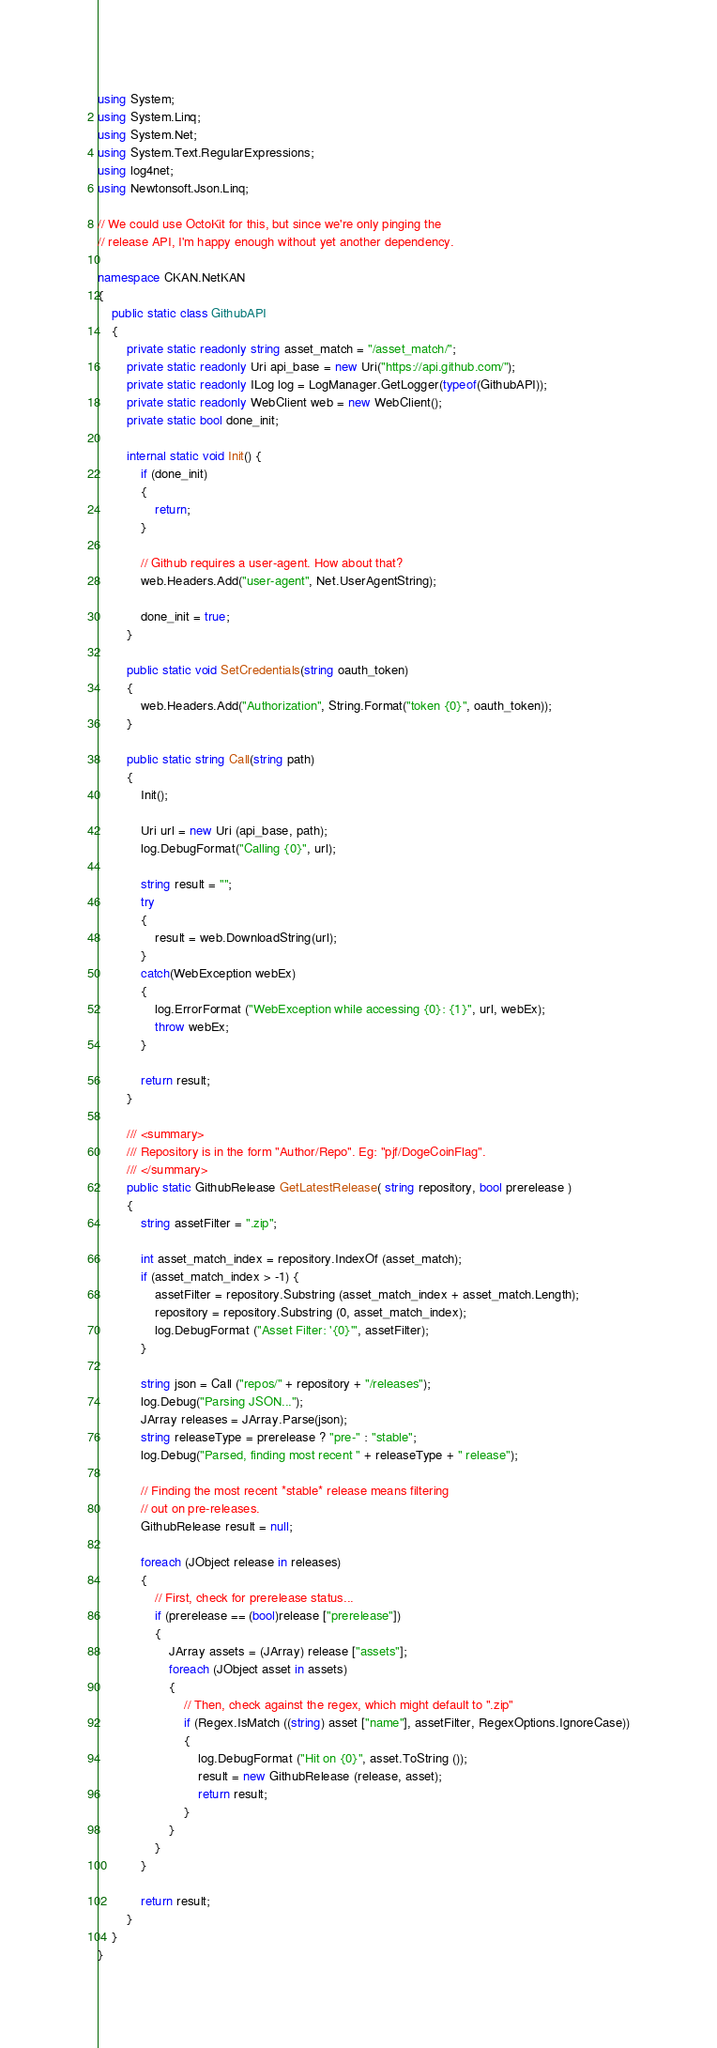<code> <loc_0><loc_0><loc_500><loc_500><_C#_>using System;
using System.Linq;
using System.Net;
using System.Text.RegularExpressions;
using log4net;
using Newtonsoft.Json.Linq;

// We could use OctoKit for this, but since we're only pinging the
// release API, I'm happy enough without yet another dependency.

namespace CKAN.NetKAN
{
    public static class GithubAPI
    {
        private static readonly string asset_match = "/asset_match/";
        private static readonly Uri api_base = new Uri("https://api.github.com/");
        private static readonly ILog log = LogManager.GetLogger(typeof(GithubAPI));
        private static readonly WebClient web = new WebClient();
        private static bool done_init;

        internal static void Init() {
            if (done_init)
            {
                return;
            }

            // Github requires a user-agent. How about that?
            web.Headers.Add("user-agent", Net.UserAgentString);

            done_init = true;
        }

        public static void SetCredentials(string oauth_token)
        {
            web.Headers.Add("Authorization", String.Format("token {0}", oauth_token));
        }

        public static string Call(string path)
        {
            Init();

            Uri url = new Uri (api_base, path);
            log.DebugFormat("Calling {0}", url);

            string result = "";
            try
            {
                result = web.DownloadString(url);
            }
            catch(WebException webEx)
            {
                log.ErrorFormat ("WebException while accessing {0}: {1}", url, webEx);
                throw webEx;
            }

            return result;
        }

        /// <summary>
        /// Repository is in the form "Author/Repo". Eg: "pjf/DogeCoinFlag".
        /// </summary>
        public static GithubRelease GetLatestRelease( string repository, bool prerelease )
        {
            string assetFilter = ".zip";

            int asset_match_index = repository.IndexOf (asset_match);
            if (asset_match_index > -1) {
                assetFilter = repository.Substring (asset_match_index + asset_match.Length);
                repository = repository.Substring (0, asset_match_index);
                log.DebugFormat ("Asset Filter: '{0}'", assetFilter);
            }

            string json = Call ("repos/" + repository + "/releases");
            log.Debug("Parsing JSON...");
            JArray releases = JArray.Parse(json);
            string releaseType = prerelease ? "pre-" : "stable";
            log.Debug("Parsed, finding most recent " + releaseType + " release");

            // Finding the most recent *stable* release means filtering
            // out on pre-releases.
            GithubRelease result = null;

            foreach (JObject release in releases)
            {
                // First, check for prerelease status...
                if (prerelease == (bool)release ["prerelease"])
                {
                    JArray assets = (JArray) release ["assets"];
                    foreach (JObject asset in assets)
                    {
                        // Then, check against the regex, which might default to ".zip"
                        if (Regex.IsMatch ((string) asset ["name"], assetFilter, RegexOptions.IgnoreCase))
                        {
                            log.DebugFormat ("Hit on {0}", asset.ToString ());
                            result = new GithubRelease (release, asset);
                            return result;
                        }
                    }
                }
            }

            return result;
        }
    }
}

</code> 